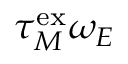Convert formula to latex. <formula><loc_0><loc_0><loc_500><loc_500>\tau _ { M } ^ { e x } \omega _ { E }</formula> 